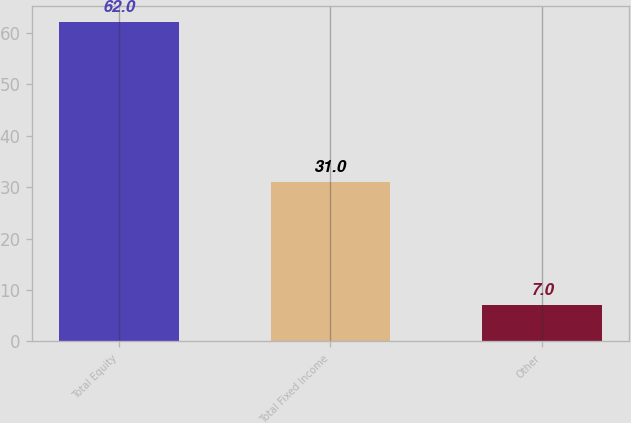<chart> <loc_0><loc_0><loc_500><loc_500><bar_chart><fcel>Total Equity<fcel>Total Fixed Income<fcel>Other<nl><fcel>62<fcel>31<fcel>7<nl></chart> 